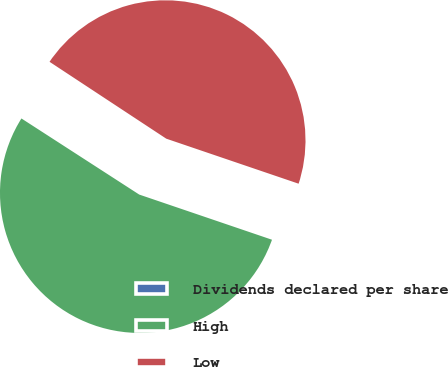Convert chart to OTSL. <chart><loc_0><loc_0><loc_500><loc_500><pie_chart><fcel>Dividends declared per share<fcel>High<fcel>Low<nl><fcel>0.14%<fcel>53.91%<fcel>45.95%<nl></chart> 